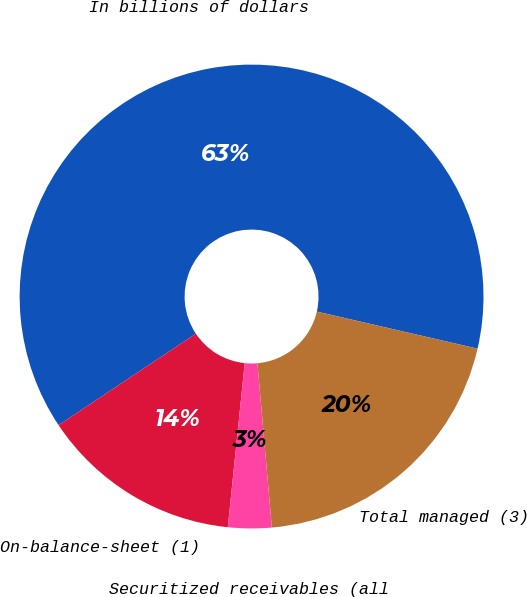Convert chart to OTSL. <chart><loc_0><loc_0><loc_500><loc_500><pie_chart><fcel>In billions of dollars<fcel>On-balance-sheet (1)<fcel>Securitized receivables (all<fcel>Total managed (3)<nl><fcel>62.97%<fcel>14.01%<fcel>3.03%<fcel>20.0%<nl></chart> 